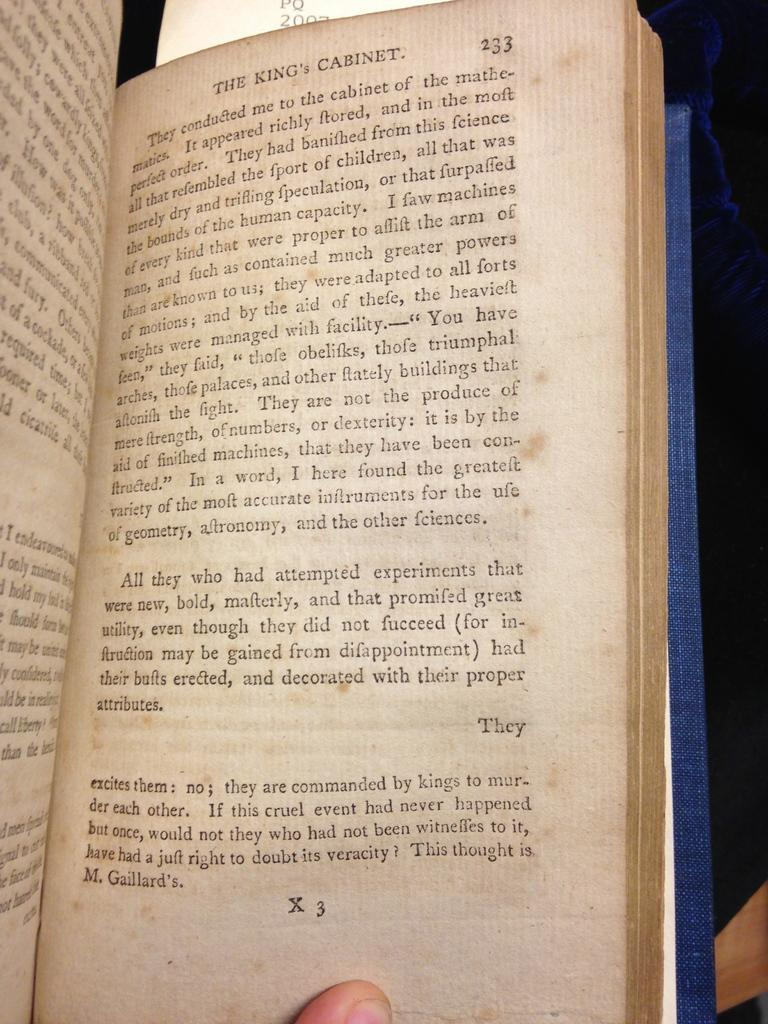<image>
Present a compact description of the photo's key features. A book is open to a chapter called The King's Cabinet. 